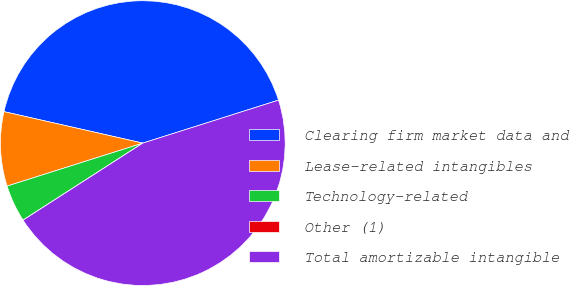Convert chart to OTSL. <chart><loc_0><loc_0><loc_500><loc_500><pie_chart><fcel>Clearing firm market data and<fcel>Lease-related intangibles<fcel>Technology-related<fcel>Other (1)<fcel>Total amortizable intangible<nl><fcel>41.57%<fcel>8.43%<fcel>4.22%<fcel>0.0%<fcel>45.78%<nl></chart> 